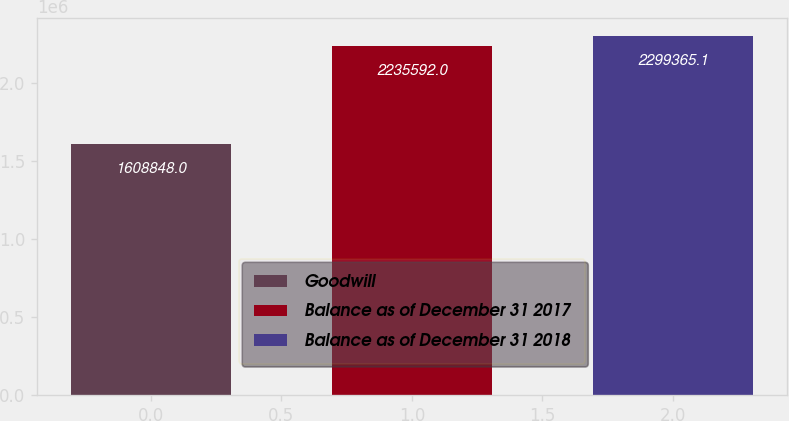Convert chart. <chart><loc_0><loc_0><loc_500><loc_500><bar_chart><fcel>Goodwill<fcel>Balance as of December 31 2017<fcel>Balance as of December 31 2018<nl><fcel>1.60885e+06<fcel>2.23559e+06<fcel>2.29937e+06<nl></chart> 